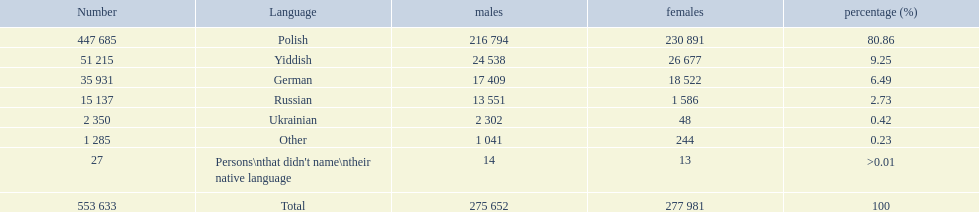Which language options are listed? Polish, Yiddish, German, Russian, Ukrainian, Other, Persons\nthat didn't name\ntheir native language. Of these, which did .42% of the people select? Ukrainian. 